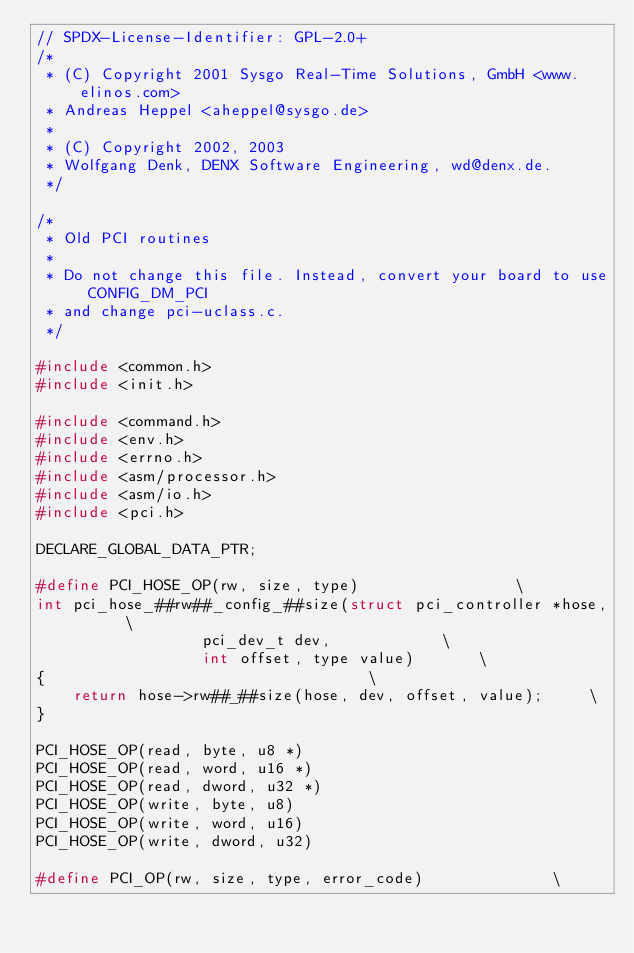<code> <loc_0><loc_0><loc_500><loc_500><_C_>// SPDX-License-Identifier: GPL-2.0+
/*
 * (C) Copyright 2001 Sysgo Real-Time Solutions, GmbH <www.elinos.com>
 * Andreas Heppel <aheppel@sysgo.de>
 *
 * (C) Copyright 2002, 2003
 * Wolfgang Denk, DENX Software Engineering, wd@denx.de.
 */

/*
 * Old PCI routines
 *
 * Do not change this file. Instead, convert your board to use CONFIG_DM_PCI
 * and change pci-uclass.c.
 */

#include <common.h>
#include <init.h>

#include <command.h>
#include <env.h>
#include <errno.h>
#include <asm/processor.h>
#include <asm/io.h>
#include <pci.h>

DECLARE_GLOBAL_DATA_PTR;

#define PCI_HOSE_OP(rw, size, type)					\
int pci_hose_##rw##_config_##size(struct pci_controller *hose,		\
				  pci_dev_t dev,			\
				  int offset, type value)		\
{									\
	return hose->rw##_##size(hose, dev, offset, value);		\
}

PCI_HOSE_OP(read, byte, u8 *)
PCI_HOSE_OP(read, word, u16 *)
PCI_HOSE_OP(read, dword, u32 *)
PCI_HOSE_OP(write, byte, u8)
PCI_HOSE_OP(write, word, u16)
PCI_HOSE_OP(write, dword, u32)

#define PCI_OP(rw, size, type, error_code)				\</code> 